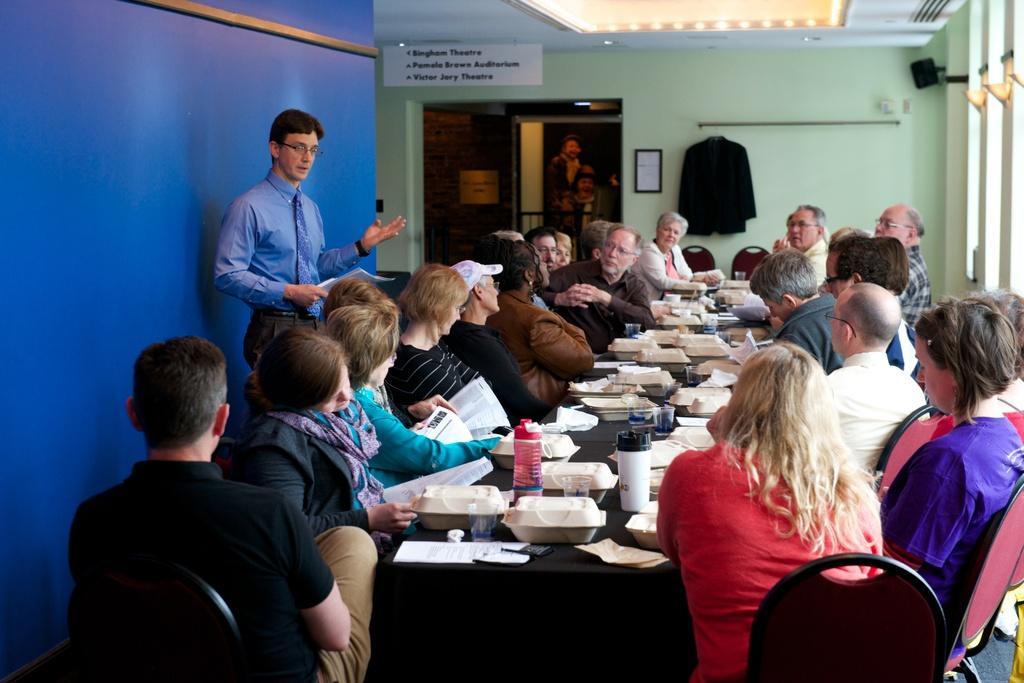Please provide a concise description of this image. This picture shows the inner view of a building, some lights, two boards with text, some objects attached to the ceiling, one shirt hanged, some chairs, some objects attached to the wall, some people standing, some people sitting on the chairs, some people are holding objects, some objects on the ground, one table with black table cloth and some objects on the table. 